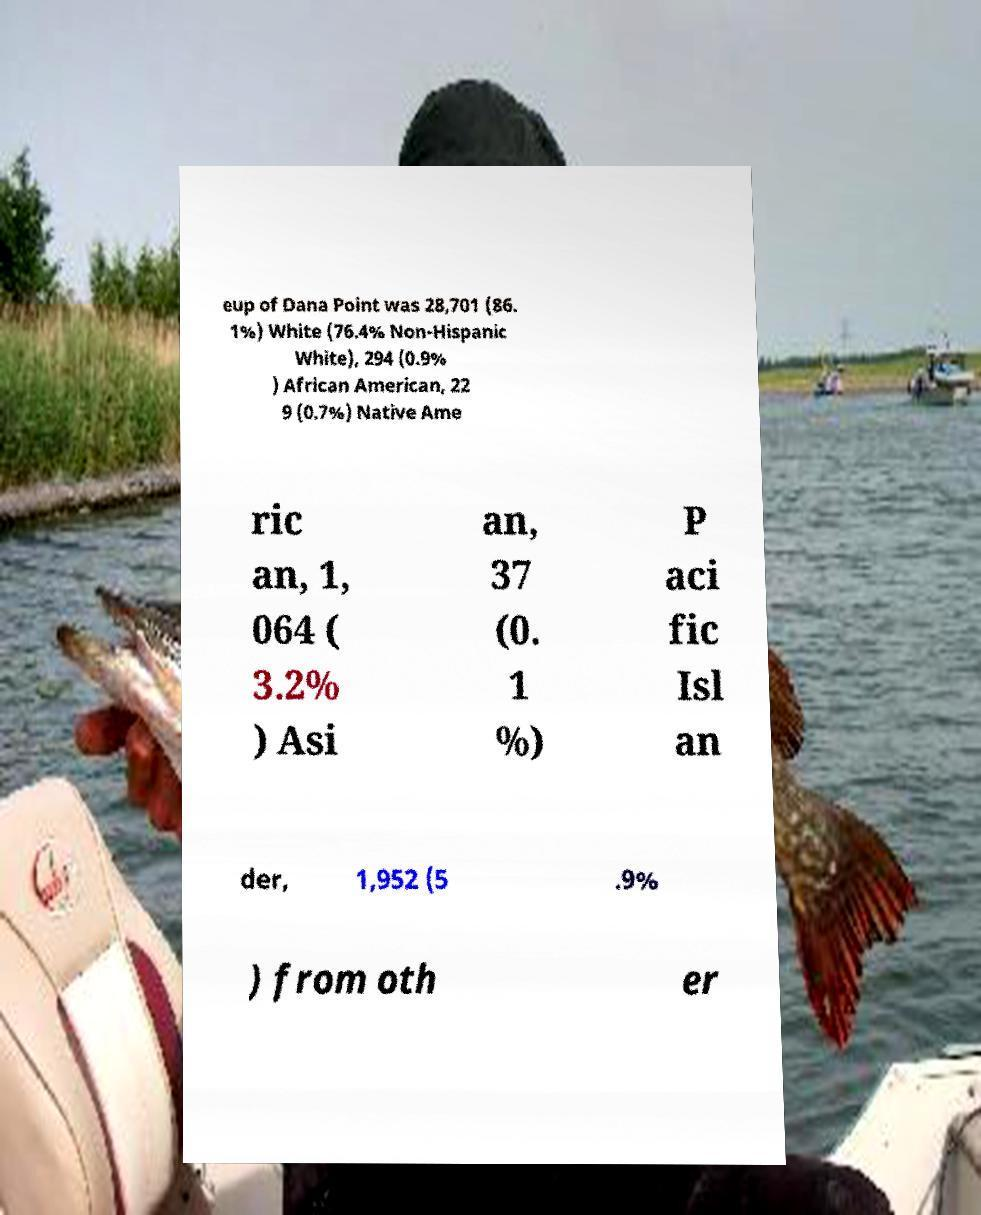There's text embedded in this image that I need extracted. Can you transcribe it verbatim? eup of Dana Point was 28,701 (86. 1%) White (76.4% Non-Hispanic White), 294 (0.9% ) African American, 22 9 (0.7%) Native Ame ric an, 1, 064 ( 3.2% ) Asi an, 37 (0. 1 %) P aci fic Isl an der, 1,952 (5 .9% ) from oth er 